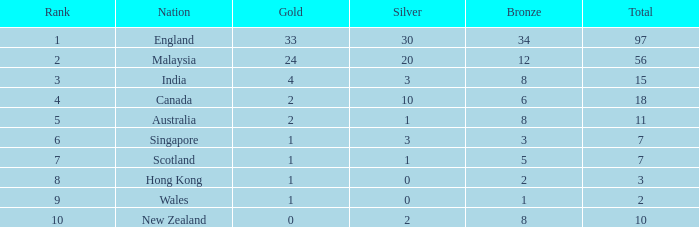What is the number of bronze that Scotland, which has less than 7 total medals, has? None. 